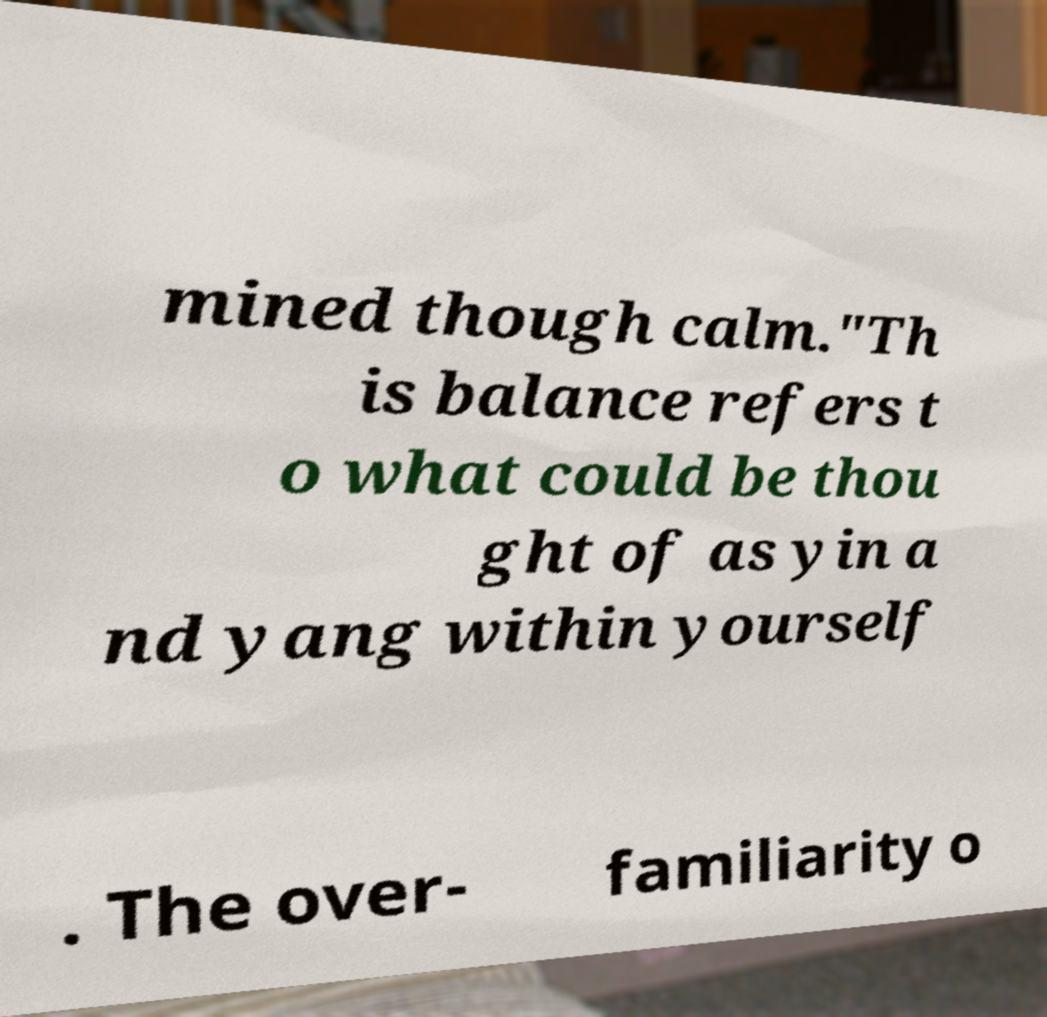I need the written content from this picture converted into text. Can you do that? mined though calm."Th is balance refers t o what could be thou ght of as yin a nd yang within yourself . The over- familiarity o 